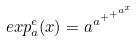Convert formula to latex. <formula><loc_0><loc_0><loc_500><loc_500>e x p _ { a } ^ { e } ( x ) = a ^ { a ^ { + ^ { + ^ { a ^ { x } } } } }</formula> 